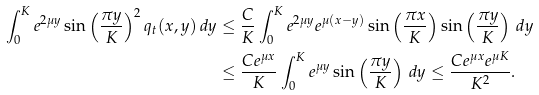<formula> <loc_0><loc_0><loc_500><loc_500>\int _ { 0 } ^ { K } e ^ { 2 \mu y } \sin \left ( \frac { \pi y } { K } \right ) ^ { 2 } q _ { t } ( x , y ) \, d y & \leq \frac { C } { K } \int _ { 0 } ^ { K } e ^ { 2 \mu y } e ^ { \mu ( x - y ) } \sin \left ( \frac { \pi x } { K } \right ) \sin \left ( \frac { \pi y } { K } \right ) \, d y \\ & \leq \frac { C e ^ { \mu x } } { K } \int _ { 0 } ^ { K } e ^ { \mu y } \sin \left ( \frac { \pi y } { K } \right ) \, d y \leq \frac { C e ^ { \mu x } e ^ { \mu K } } { K ^ { 2 } } .</formula> 